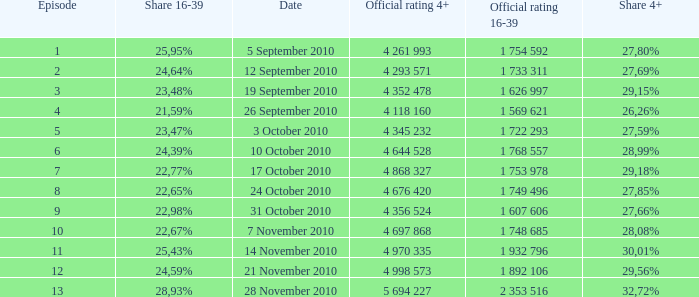What is the official rating 16-39 for the episode with  a 16-39 share of 22,77%? 1 753 978. 